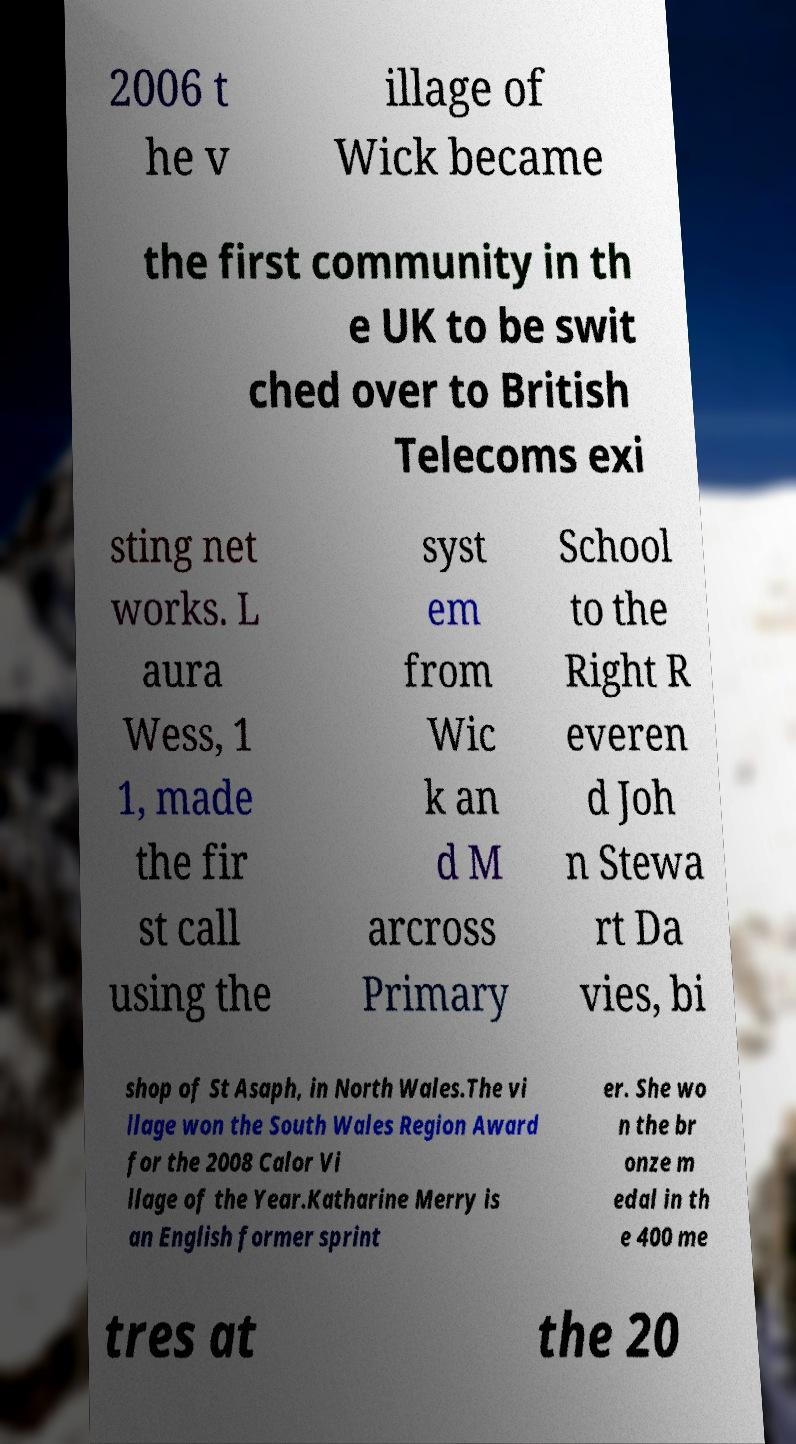Can you read and provide the text displayed in the image?This photo seems to have some interesting text. Can you extract and type it out for me? 2006 t he v illage of Wick became the first community in th e UK to be swit ched over to British Telecoms exi sting net works. L aura Wess, 1 1, made the fir st call using the syst em from Wic k an d M arcross Primary School to the Right R everen d Joh n Stewa rt Da vies, bi shop of St Asaph, in North Wales.The vi llage won the South Wales Region Award for the 2008 Calor Vi llage of the Year.Katharine Merry is an English former sprint er. She wo n the br onze m edal in th e 400 me tres at the 20 